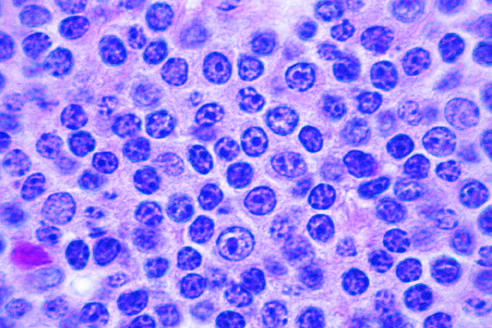what appearance do a majority of the tumor cells have?
Answer the question using a single word or phrase. Small 